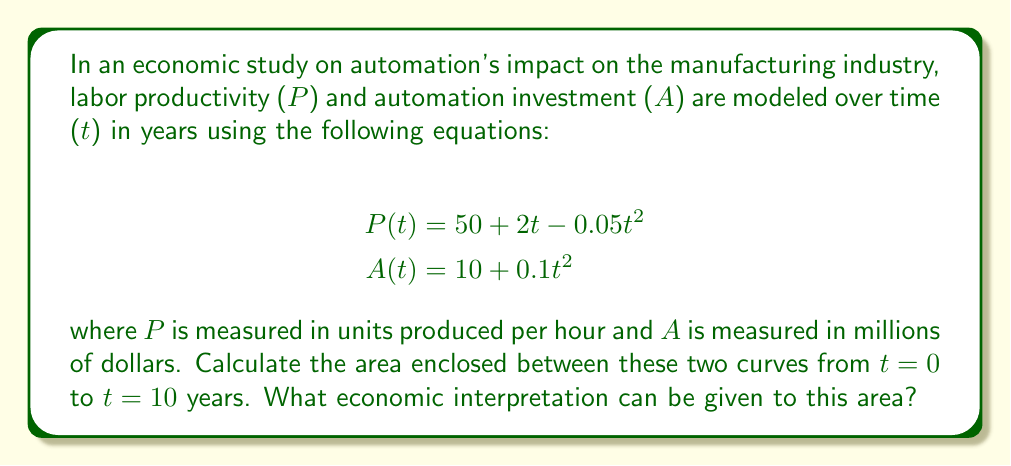Can you answer this question? To find the area enclosed between the two curves, we need to:

1. Find the points of intersection of the curves
2. Calculate the definite integral of the difference between the curves

Step 1: Find the points of intersection
Set P(t) = A(t) and solve for t:

$$50 + 2t - 0.05t^2 = 10 + 0.1t^2$$
$$40 + 2t = 0.15t^2$$
$$0.15t^2 - 2t - 40 = 0$$

Using the quadratic formula:

$$t = \frac{2 \pm \sqrt{4 + 4(0.15)(40)}}{2(0.15)} = \frac{2 \pm \sqrt{28}}{0.3}$$

$$t_1 \approx 0.83 \text{ years}, t_2 \approx 12.50 \text{ years}$$

Step 2: Calculate the definite integral
The area is given by:

$$\text{Area} = \int_{0}^{10} [P(t) - A(t)] dt$$

$$= \int_{0}^{10} [(50 + 2t - 0.05t^2) - (10 + 0.1t^2)] dt$$

$$= \int_{0}^{10} [40 + 2t - 0.15t^2] dt$$

$$= [40t + t^2 - 0.05t^3]_{0}^{10}$$

$$= (400 + 100 - 50) - (0 + 0 - 0) = 450$$

Economic interpretation: The area represents the cumulative difference between labor productivity and automation investment over the 10-year period. A positive value indicates that productivity gains outpaced automation investments during this time, suggesting a net benefit to the industry.

[asy]
import graph;
size(200,150);
real f(real x) {return 50 + 2x - 0.05x^2;}
real g(real x) {return 10 + 0.1x^2;}
draw(graph(f,0,10),blue,"P(t)");
draw(graph(g,0,10),red,"A(t)");
xaxis("t (years)",0,10,Arrow);
yaxis("Value",0,70,Arrow);
label("P(t)",(-0.5,f(0)),W,blue);
label("A(t)",(-0.5,g(0)),W,red);
fill(graph(f,0,10)--graph(g,10,0)--cycle,paleblue);
[/asy]
Answer: The area enclosed between the curves from t = 0 to t = 10 years is 450 units (e.g., million dollar-hours). This represents the cumulative excess of labor productivity over automation investment during the period, indicating a net positive impact on the manufacturing industry. 